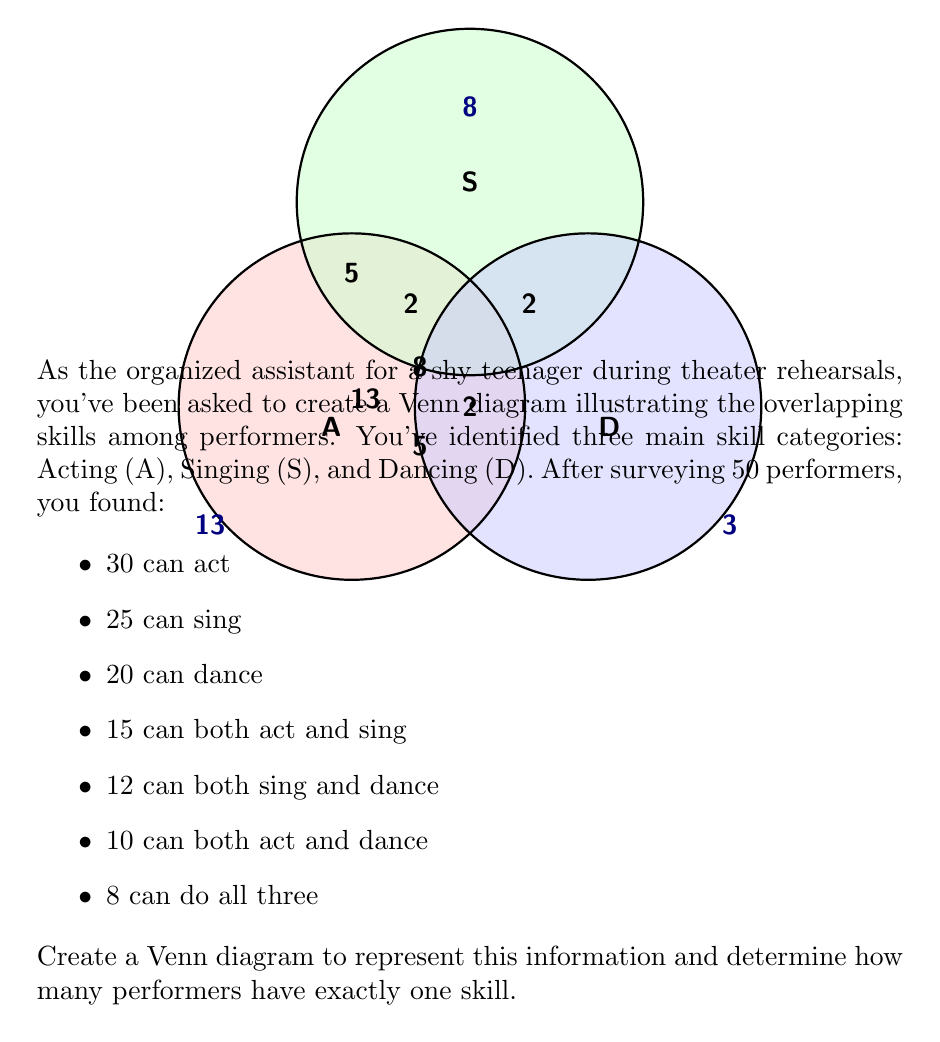Could you help me with this problem? Let's approach this step-by-step:

1) First, we need to fill in the Venn diagram. We'll start with the center, where all three skills overlap:
   $n(A \cap S \cap D) = 8$

2) Next, we'll fill in the pairwise intersections:
   $n(A \cap S) - n(A \cap S \cap D) = 15 - 8 = 7$
   $n(S \cap D) - n(A \cap S \cap D) = 12 - 8 = 4$
   $n(A \cap D) - n(A \cap S \cap D) = 10 - 8 = 2$

3) Now, we can calculate the number in each circle that don't overlap with others:
   Acting only: $n(A) - n(A \cap S) - n(A \cap D) + n(A \cap S \cap D) = 30 - 15 - 10 + 8 = 13$
   Singing only: $n(S) - n(A \cap S) - n(S \cap D) + n(A \cap S \cap D) = 25 - 15 - 12 + 8 = 6$
   Dancing only: $n(D) - n(A \cap D) - n(S \cap D) + n(A \cap S \cap D) = 20 - 10 - 12 + 8 = 6$

4) To find the number of performers with exactly one skill, we sum the numbers in each circle that don't overlap:
   $13 + 6 + 6 = 25$

5) We can verify our result by adding up all the numbers in the Venn diagram:
   $8 + 7 + 4 + 2 + 13 + 6 + 6 = 46$
   This leaves 4 performers outside all circles, which is correct as $50 - 46 = 4$.
Answer: 25 performers have exactly one skill. 